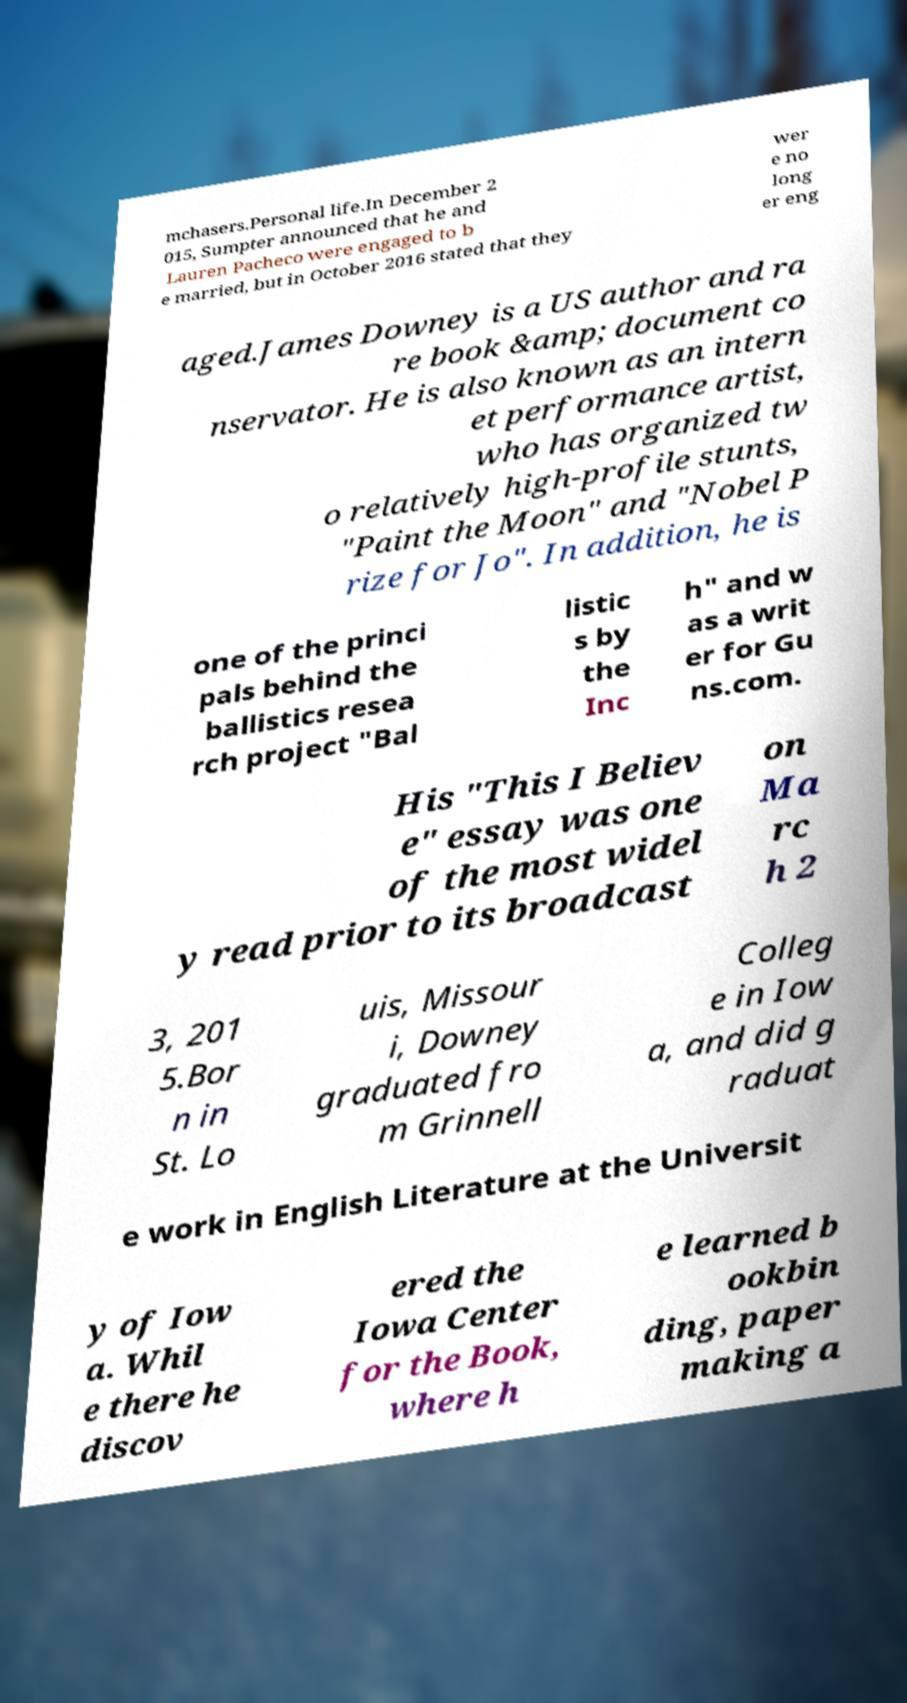Could you extract and type out the text from this image? mchasers.Personal life.In December 2 015, Sumpter announced that he and Lauren Pacheco were engaged to b e married, but in October 2016 stated that they wer e no long er eng aged.James Downey is a US author and ra re book &amp; document co nservator. He is also known as an intern et performance artist, who has organized tw o relatively high-profile stunts, "Paint the Moon" and "Nobel P rize for Jo". In addition, he is one of the princi pals behind the ballistics resea rch project "Bal listic s by the Inc h" and w as a writ er for Gu ns.com. His "This I Believ e" essay was one of the most widel y read prior to its broadcast on Ma rc h 2 3, 201 5.Bor n in St. Lo uis, Missour i, Downey graduated fro m Grinnell Colleg e in Iow a, and did g raduat e work in English Literature at the Universit y of Iow a. Whil e there he discov ered the Iowa Center for the Book, where h e learned b ookbin ding, paper making a 